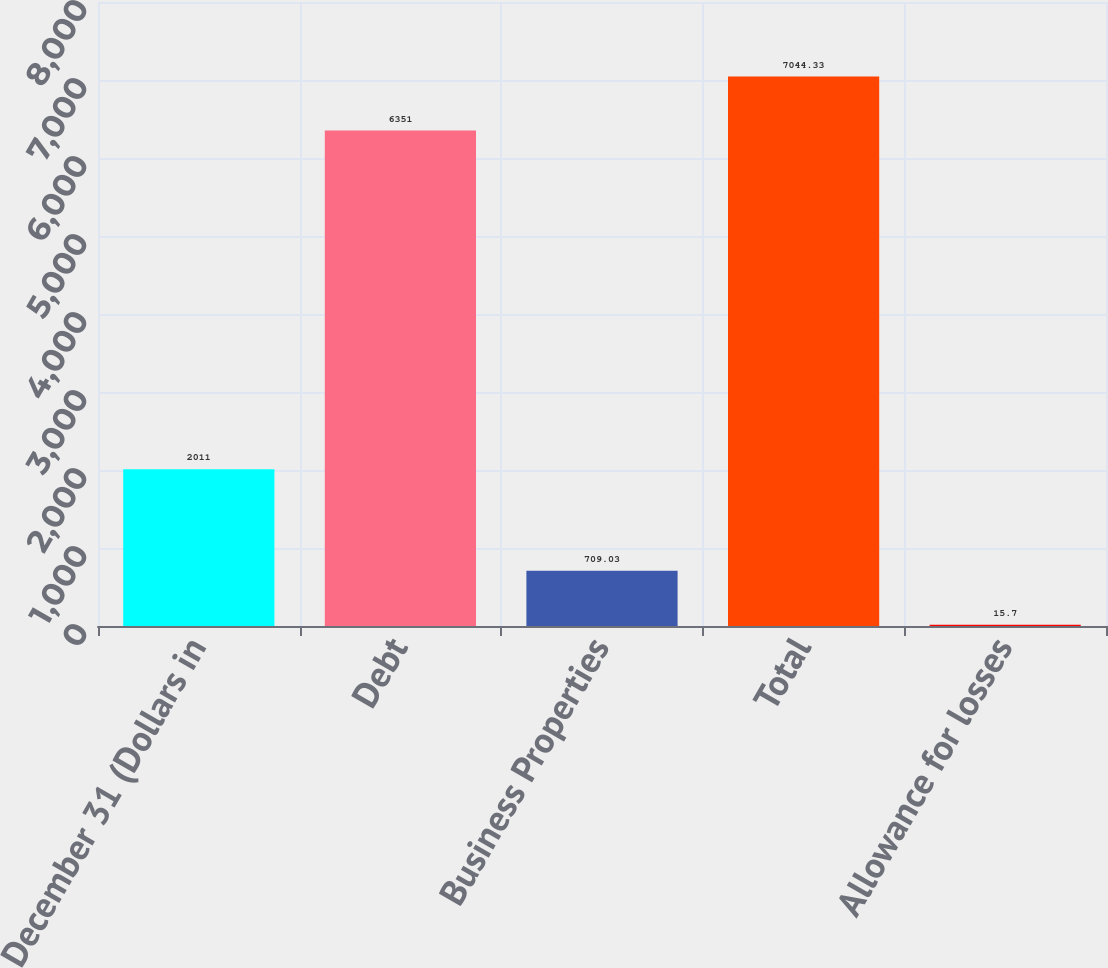Convert chart to OTSL. <chart><loc_0><loc_0><loc_500><loc_500><bar_chart><fcel>December 31 (Dollars in<fcel>Debt<fcel>Business Properties<fcel>Total<fcel>Allowance for losses<nl><fcel>2011<fcel>6351<fcel>709.03<fcel>7044.33<fcel>15.7<nl></chart> 